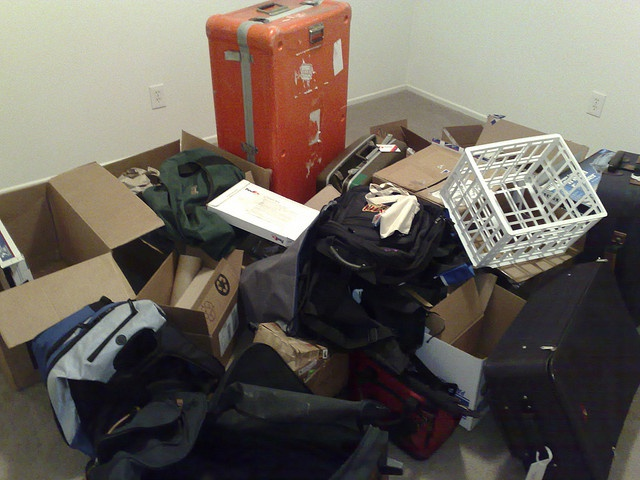Describe the objects in this image and their specific colors. I can see suitcase in beige, black, gray, and darkgreen tones, suitcase in beige, black, gray, and darkgreen tones, backpack in beige, black, darkgray, gray, and darkblue tones, suitcase in beige, brown, and maroon tones, and backpack in beige, black, darkgray, and tan tones in this image. 